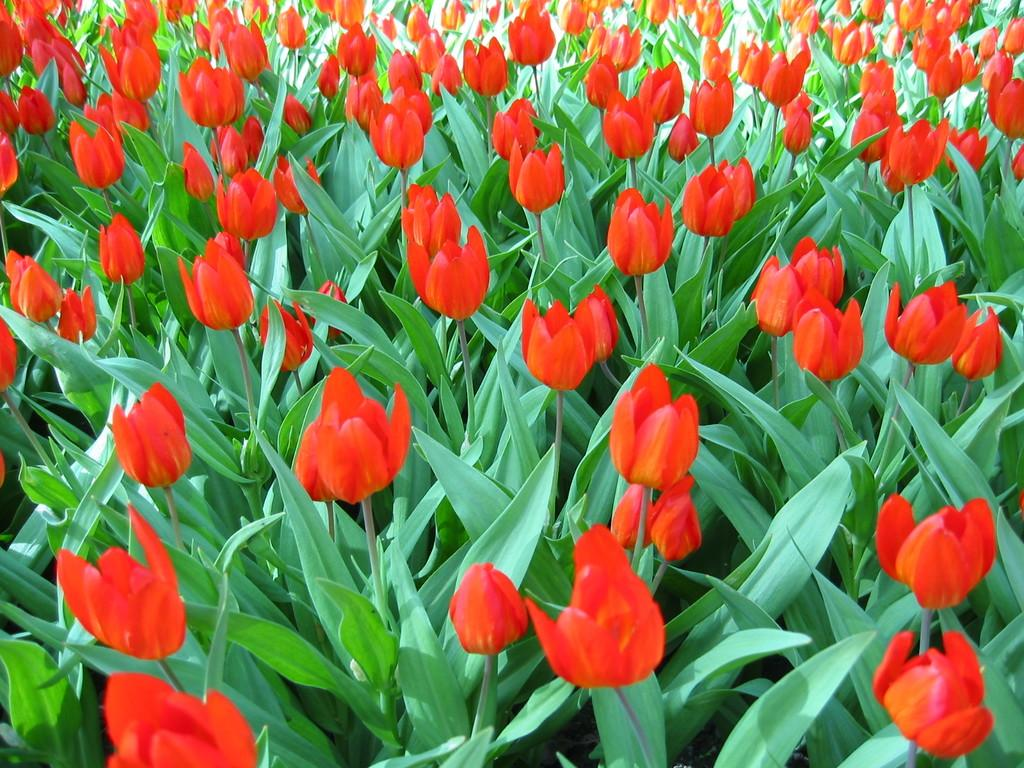What type of living organisms can be seen in the image? Plants can be seen in the image. What color are the flowers on the plants? The flowers on the plants are red-colored Tulip flowers. What type of cakes is the carpenter making on the table in the image? There is no carpenter or table present in the image; it only features plants with red-colored Tulip flowers. 